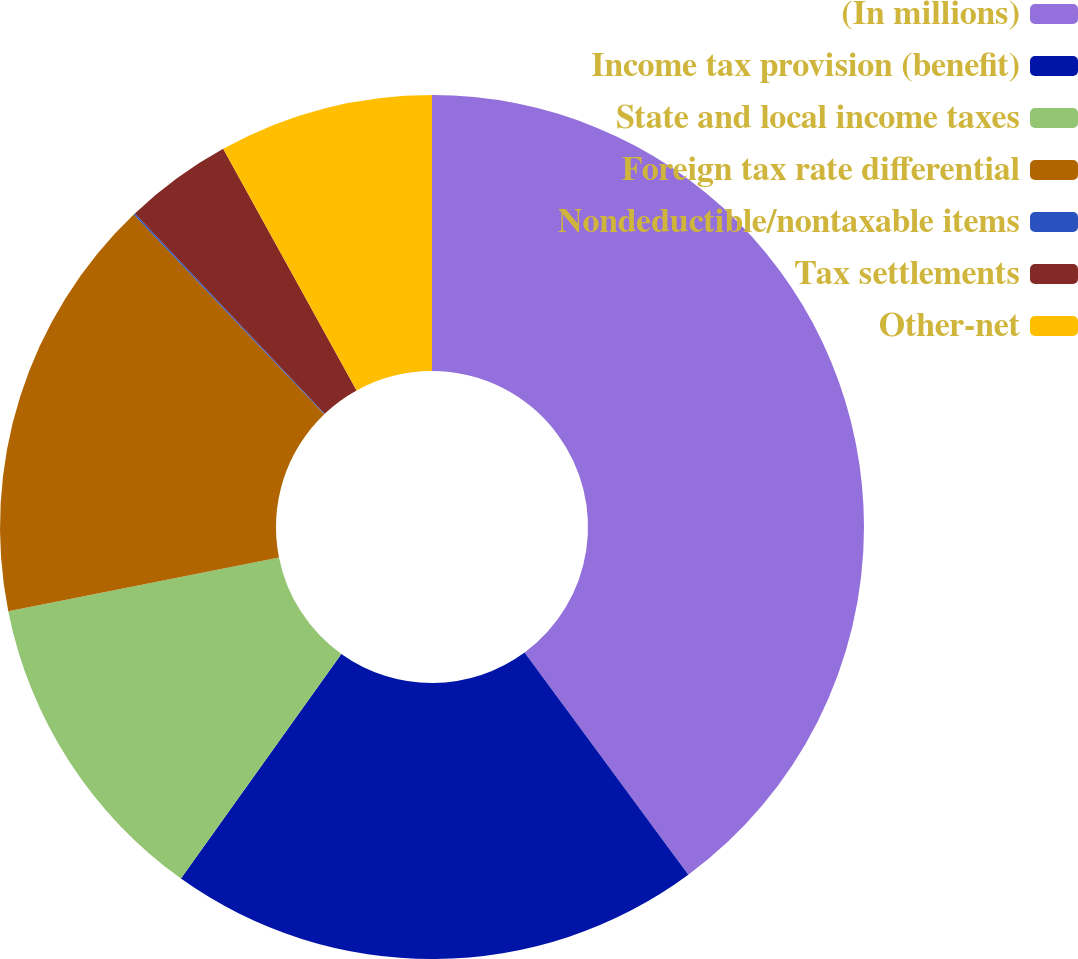<chart> <loc_0><loc_0><loc_500><loc_500><pie_chart><fcel>(In millions)<fcel>Income tax provision (benefit)<fcel>State and local income taxes<fcel>Foreign tax rate differential<fcel>Nondeductible/nontaxable items<fcel>Tax settlements<fcel>Other-net<nl><fcel>39.89%<fcel>19.98%<fcel>12.01%<fcel>15.99%<fcel>0.06%<fcel>4.04%<fcel>8.03%<nl></chart> 